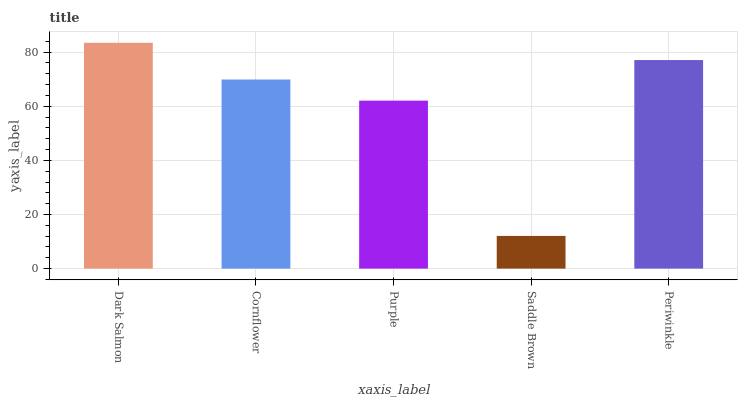Is Saddle Brown the minimum?
Answer yes or no. Yes. Is Dark Salmon the maximum?
Answer yes or no. Yes. Is Cornflower the minimum?
Answer yes or no. No. Is Cornflower the maximum?
Answer yes or no. No. Is Dark Salmon greater than Cornflower?
Answer yes or no. Yes. Is Cornflower less than Dark Salmon?
Answer yes or no. Yes. Is Cornflower greater than Dark Salmon?
Answer yes or no. No. Is Dark Salmon less than Cornflower?
Answer yes or no. No. Is Cornflower the high median?
Answer yes or no. Yes. Is Cornflower the low median?
Answer yes or no. Yes. Is Dark Salmon the high median?
Answer yes or no. No. Is Purple the low median?
Answer yes or no. No. 